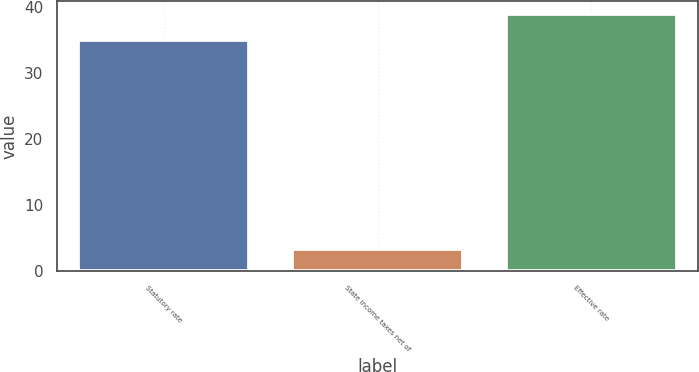Convert chart to OTSL. <chart><loc_0><loc_0><loc_500><loc_500><bar_chart><fcel>Statutory rate<fcel>State income taxes net of<fcel>Effective rate<nl><fcel>35<fcel>3.4<fcel>39<nl></chart> 